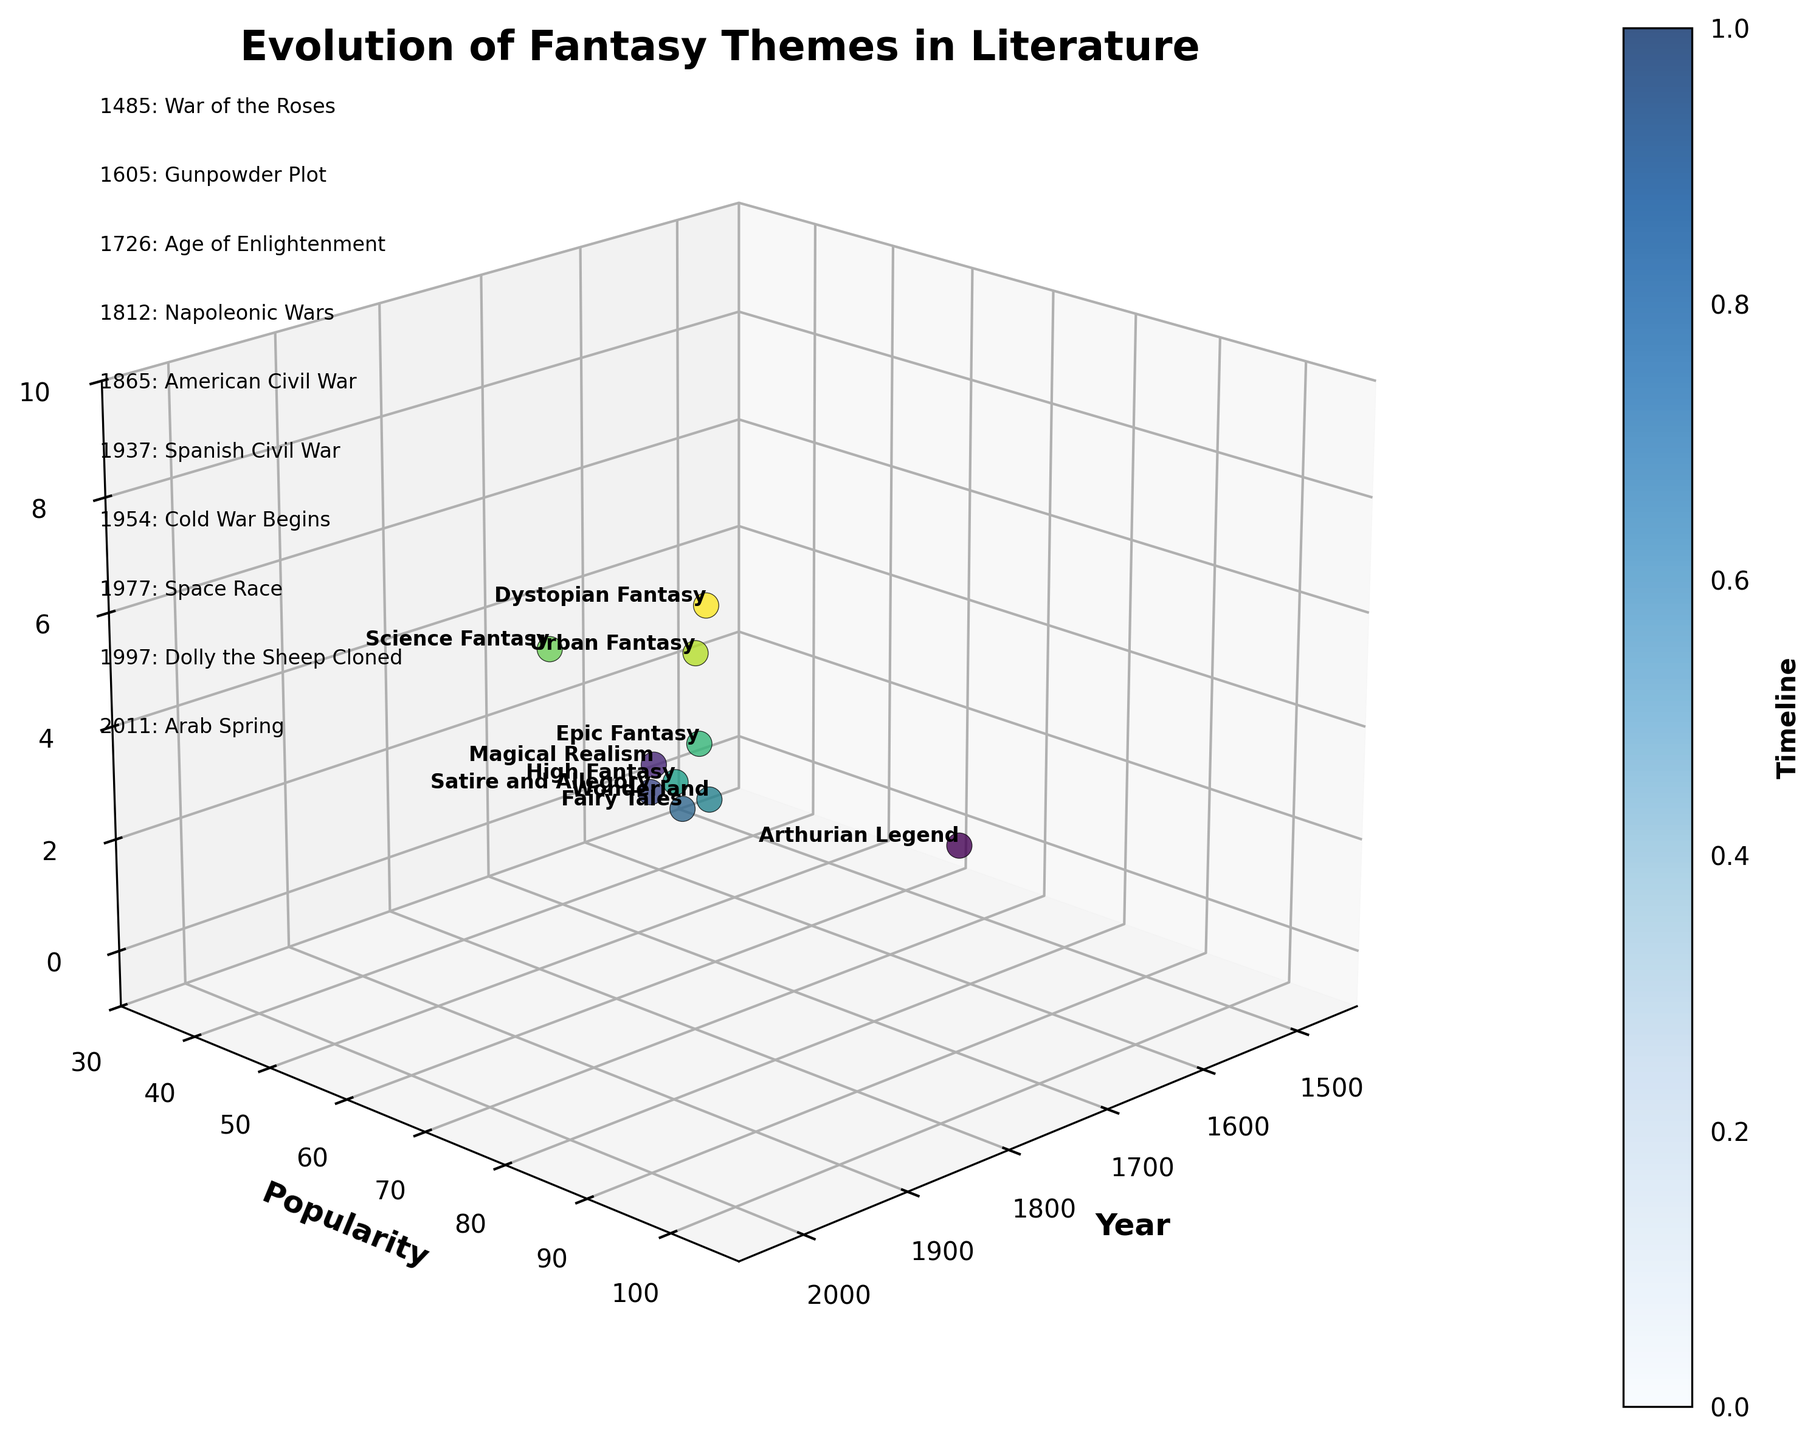What is the title of the 3D plot? The title of the plot is located at the top of the figure, prominently displayed to indicate the subject of the visualization.
Answer: Evolution of Fantasy Themes in Literature How many fantasy themes are plotted in the figure? Each fantasy theme is represented by a distinct point labeled with its name in the 3D space. Count these labels to determine the number of themes.
Answer: 10 Which fantasy theme has the highest popularity? Observe the 'Popularity' axis and find the label at the highest point on this axis.
Answer: Dystopian Fantasy Between which two historical events did Fairy Tales become popular? Identify the 'Fairy Tales' label and trace the corresponding 'Year' to find the historical events immediately before and after.
Answer: Napoleonic Wars and American Civil War What is the average popularity of the fantasy themes from 1900 to 2000? Identify the fantasy themes within 1900 to 2000, sum their popularity values, and divide by the count of these themes.
Answer: (85 + 90 + 75 + 95) / 4 = 86.25 Which fantasy theme emerged first, and what was the historical event associated with it? Find the earliest year on the plot and note the fantasy theme and corresponding historical event.
Answer: Arthurian Legend, War of the Roses Is there a correlation between fantasy theme popularity and historical events? Analyze the z-axis (Fantasy Themes) and the context of the historical events marked on the 3D plot to discern patterns or trends.
Answer: Yes Which fantasy theme had a major historical event happening in the same year it became popular? Check the plot for any year where the theme’s popularity coincides exactly with a significant historical event.
Answer: Arthurian Legend (War of the Roses) How does the popularity of Urban Fantasy compare to Science Fantasy? Observe the 'Popularity' axis values for Urban Fantasy and Science Fantasy and compare them.
Answer: Urban Fantasy (95) is higher than Science Fantasy (75) What is the chronological order of the fantasy themes based on their emergence? Follow the 'Year' axis from the earliest to the latest and list the fantasy themes in that sequence.
Answer: Arthurian Legend, Magical Realism, Satire and Allegory, Fairy Tales, Wonderland, High Fantasy, Epic Fantasy, Science Fantasy, Urban Fantasy, Dystopian Fantasy 